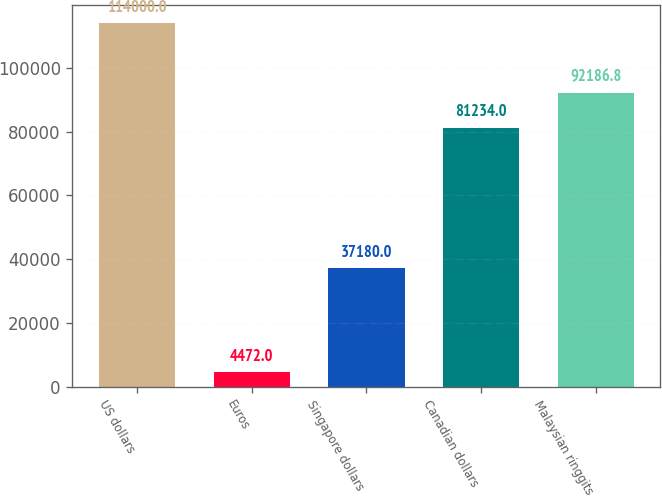<chart> <loc_0><loc_0><loc_500><loc_500><bar_chart><fcel>US dollars<fcel>Euros<fcel>Singapore dollars<fcel>Canadian dollars<fcel>Malaysian ringgits<nl><fcel>114000<fcel>4472<fcel>37180<fcel>81234<fcel>92186.8<nl></chart> 